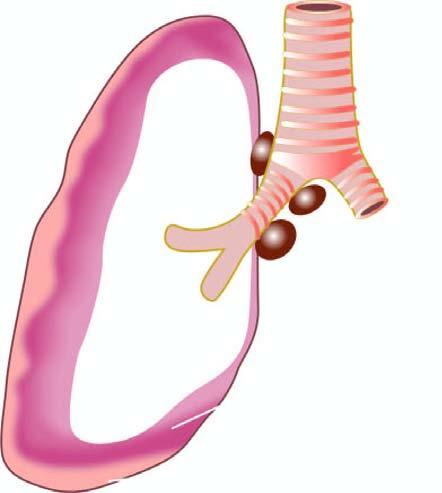s each fibril seen to form a thick, white, fleshy coat over the parietal and visceral surfaces?
Answer the question using a single word or phrase. No 